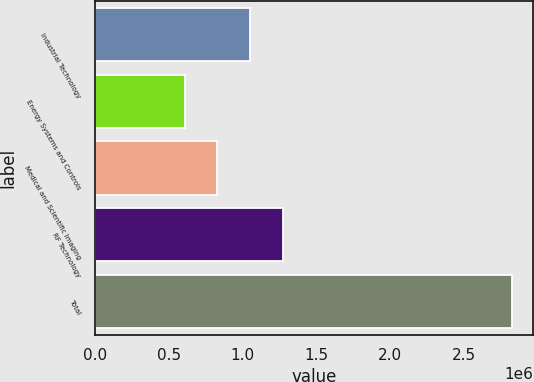Convert chart to OTSL. <chart><loc_0><loc_0><loc_500><loc_500><bar_chart><fcel>Industrial Technology<fcel>Energy Systems and Controls<fcel>Medical and Scientific Imaging<fcel>RF Technology<fcel>Total<nl><fcel>1.05148e+06<fcel>608538<fcel>830009<fcel>1.27295e+06<fcel>2.82325e+06<nl></chart> 